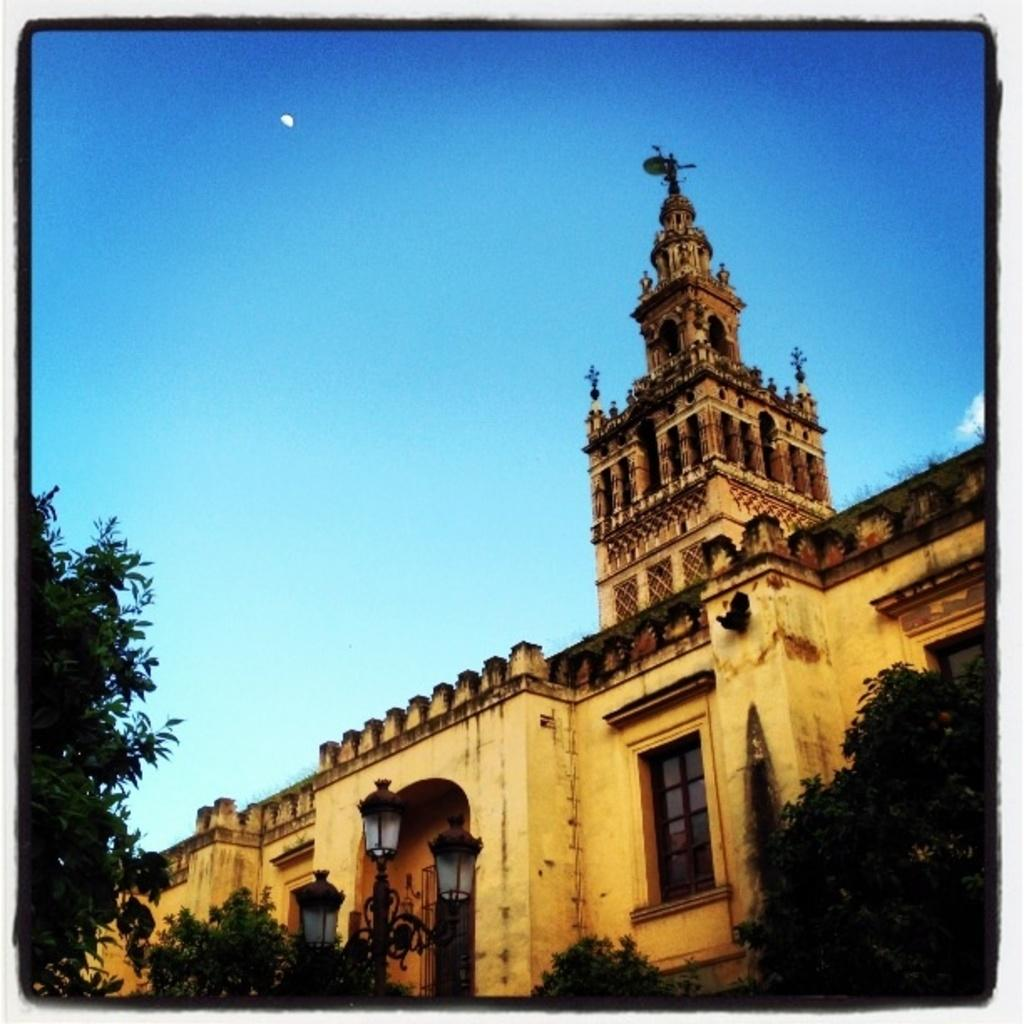What type of natural elements can be seen in the image? There are trees in the image. What artificial elements can be seen in the image? There are lights and a building in the image. What is visible in the background of the image? The sky is visible in the background of the image. What type of cast can be seen performing an operation in the image? There is no cast or operation present in the image. What color is the van parked near the building in the image? There is no van present in the image. 